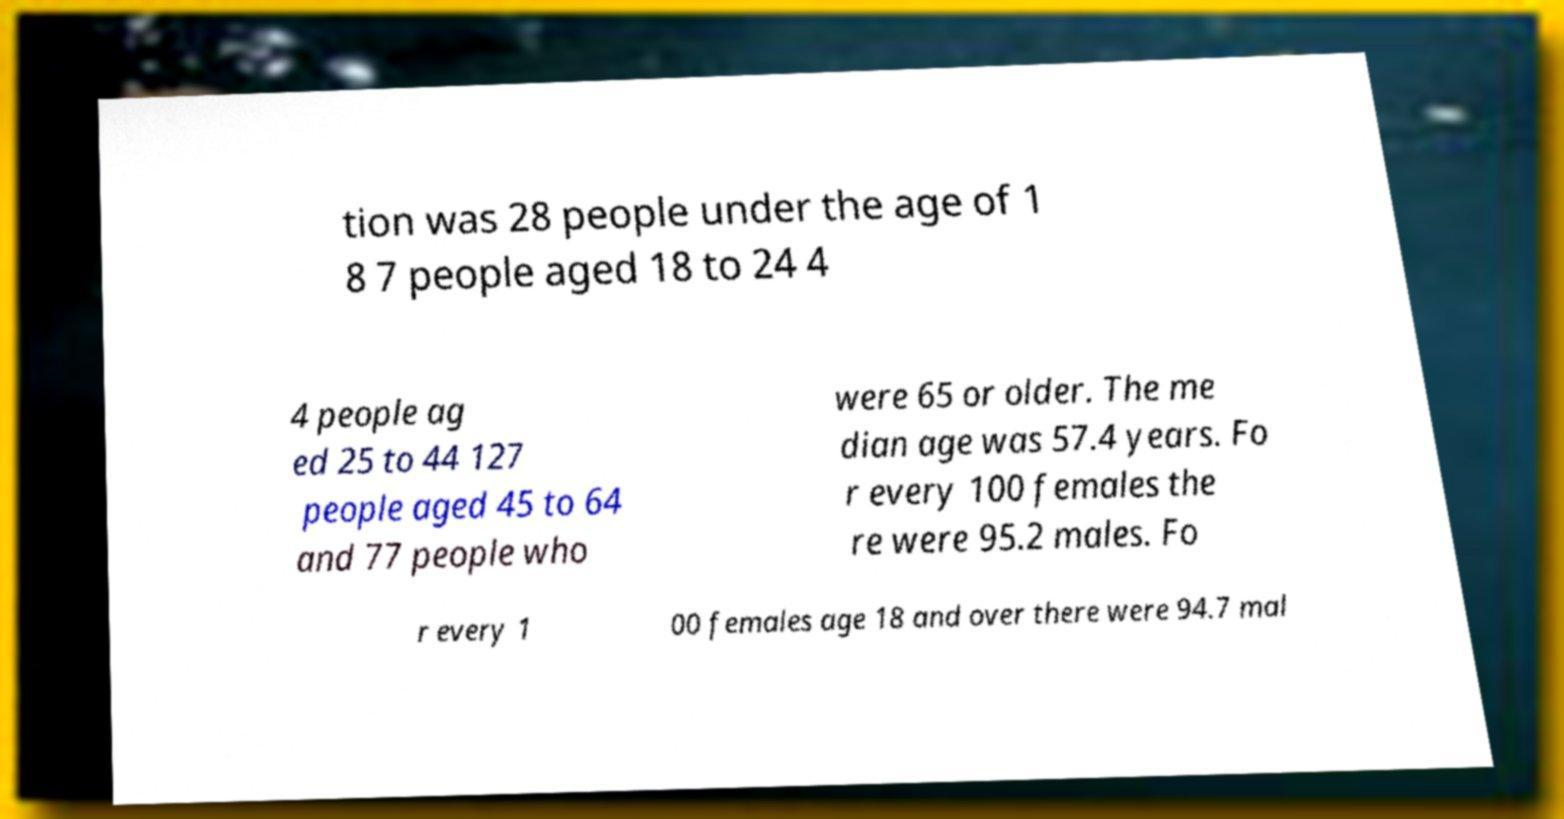What messages or text are displayed in this image? I need them in a readable, typed format. tion was 28 people under the age of 1 8 7 people aged 18 to 24 4 4 people ag ed 25 to 44 127 people aged 45 to 64 and 77 people who were 65 or older. The me dian age was 57.4 years. Fo r every 100 females the re were 95.2 males. Fo r every 1 00 females age 18 and over there were 94.7 mal 